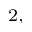Convert formula to latex. <formula><loc_0><loc_0><loc_500><loc_500>^ { 2 , }</formula> 